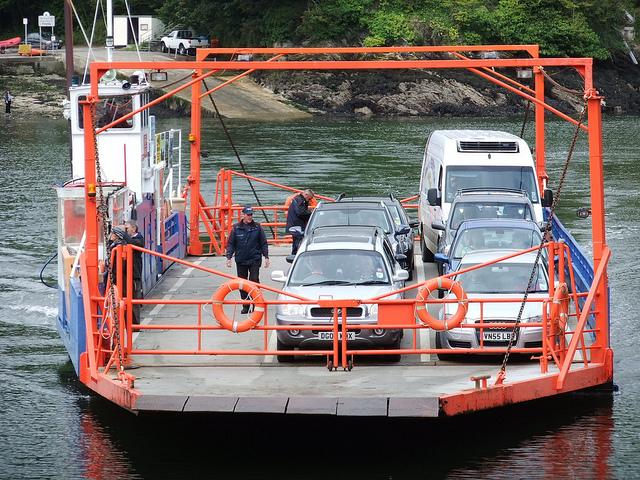Why are the vehicles on the boat? Please explain your reasoning. cross water. The vehicles on the boat can't traverse water so they need the boat to get across, which is what's happening here. 